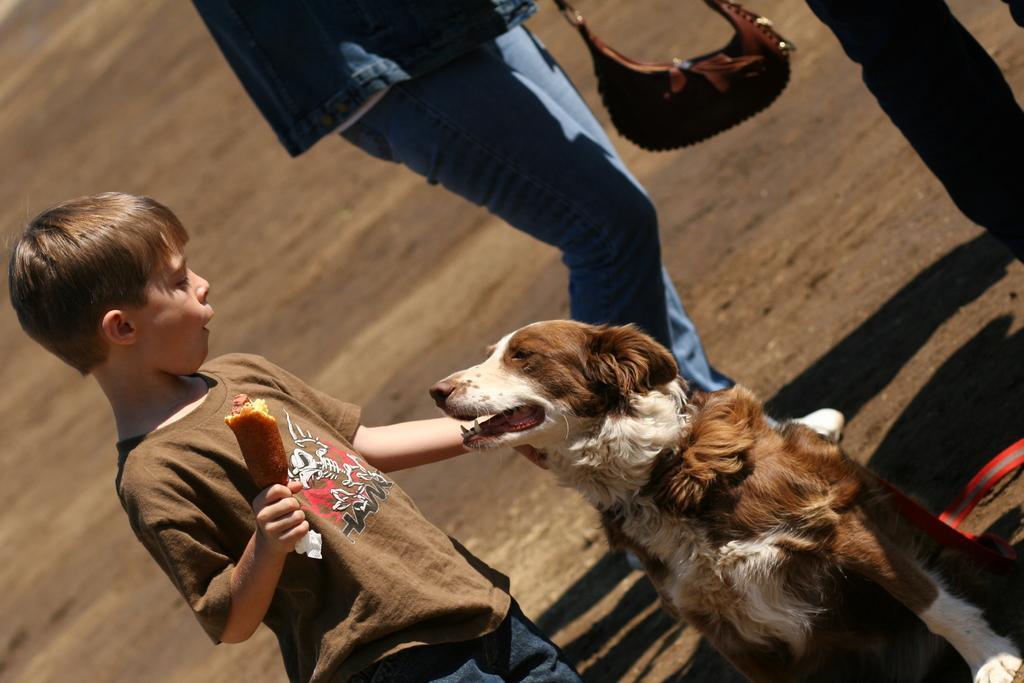Describe this image in one or two sentences. Here we can see a child with a dog in front of him and he is holding something in his hand and behind him we can see a person standing and there is a bag present 